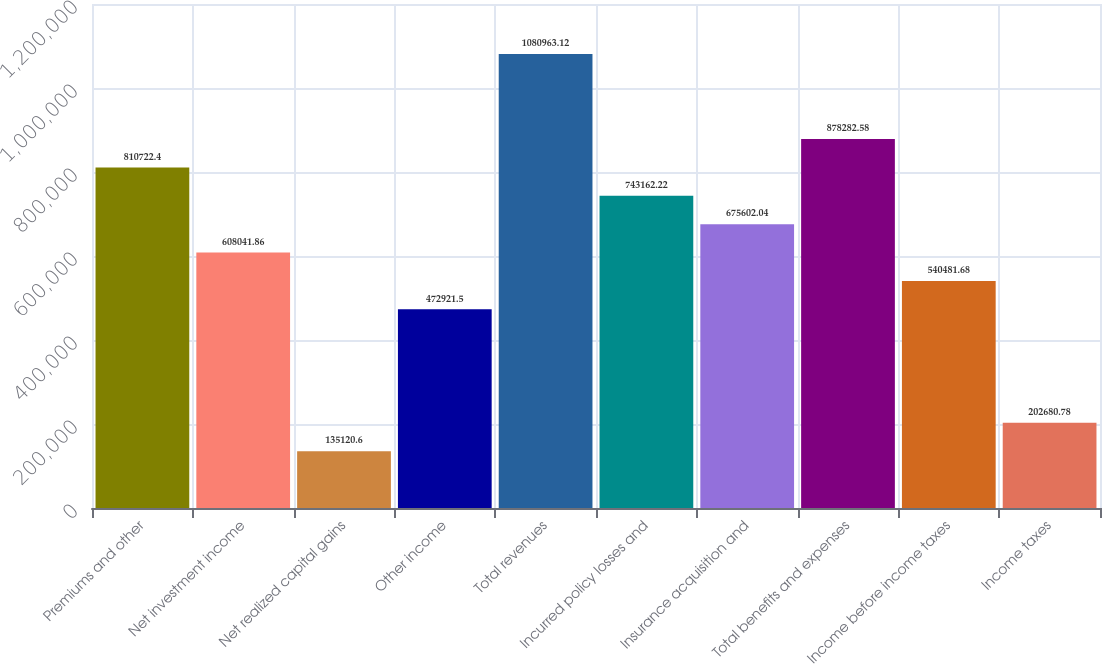Convert chart. <chart><loc_0><loc_0><loc_500><loc_500><bar_chart><fcel>Premiums and other<fcel>Net investment income<fcel>Net realized capital gains<fcel>Other income<fcel>Total revenues<fcel>Incurred policy losses and<fcel>Insurance acquisition and<fcel>Total benefits and expenses<fcel>Income before income taxes<fcel>Income taxes<nl><fcel>810722<fcel>608042<fcel>135121<fcel>472922<fcel>1.08096e+06<fcel>743162<fcel>675602<fcel>878283<fcel>540482<fcel>202681<nl></chart> 